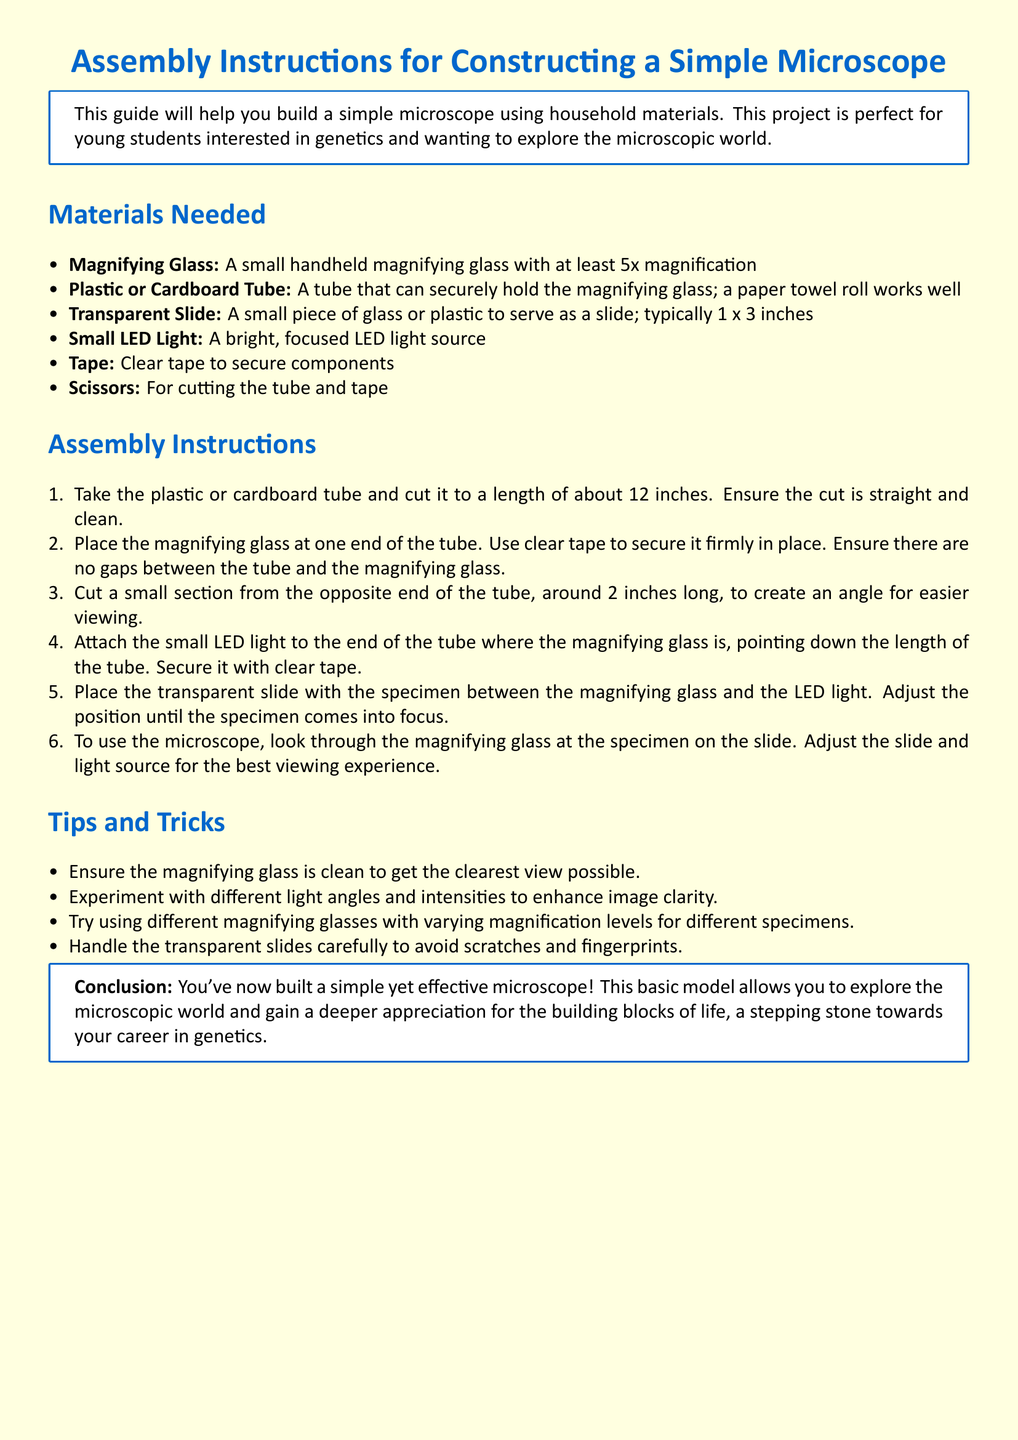What is the minimum magnification of the magnifying glass? The document specifies that the magnifying glass should have at least 5x magnification.
Answer: 5x How long should the plastic or cardboard tube be cut? The assembly instructions state that the tube should be cut to a length of about 12 inches.
Answer: 12 inches What is used to secure the magnifying glass to the tube? The instructions indicate that clear tape is used to secure the magnifying glass firmly in place.
Answer: Clear tape How long of a section should be cut from the opposite end of the tube? The document mentions cutting around 2 inches long from the opposite end of the tube.
Answer: 2 inches What is the purpose of the small LED light? The LED light is attached to provide a bright, focused light source for viewing specimens.
Answer: Viewing specimens What material can be used as a slide? The document states that a small piece of glass or plastic can serve as a slide.
Answer: Glass or plastic What is one tip provided for enhancing image clarity? The tips suggest experimenting with different light angles and intensities to enhance clarity.
Answer: Light angles What final conclusion is given in the document? The conclusion states that you've built a simple yet effective microscope to explore the microscopic world.
Answer: Explore the microscopic world 